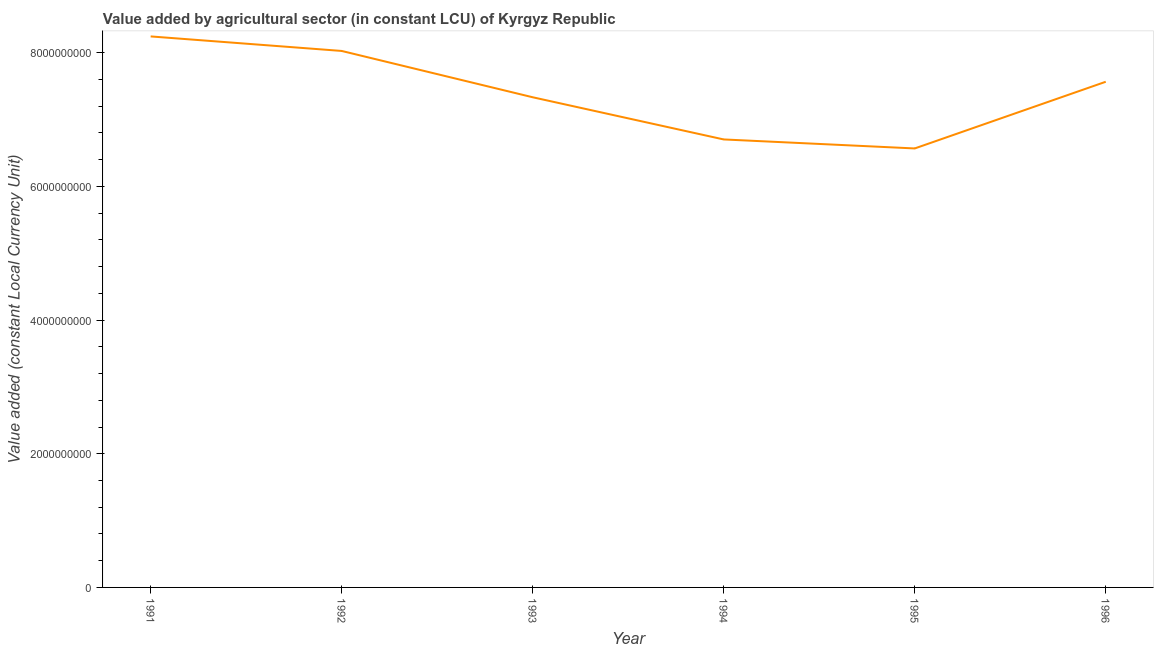What is the value added by agriculture sector in 1996?
Provide a succinct answer. 7.57e+09. Across all years, what is the maximum value added by agriculture sector?
Make the answer very short. 8.24e+09. Across all years, what is the minimum value added by agriculture sector?
Give a very brief answer. 6.57e+09. In which year was the value added by agriculture sector minimum?
Make the answer very short. 1995. What is the sum of the value added by agriculture sector?
Your answer should be very brief. 4.44e+1. What is the difference between the value added by agriculture sector in 1995 and 1996?
Provide a succinct answer. -9.98e+08. What is the average value added by agriculture sector per year?
Give a very brief answer. 7.41e+09. What is the median value added by agriculture sector?
Provide a succinct answer. 7.45e+09. What is the ratio of the value added by agriculture sector in 1991 to that in 1994?
Ensure brevity in your answer.  1.23. Is the value added by agriculture sector in 1992 less than that in 1994?
Your answer should be compact. No. What is the difference between the highest and the second highest value added by agriculture sector?
Provide a succinct answer. 2.17e+08. What is the difference between the highest and the lowest value added by agriculture sector?
Offer a very short reply. 1.68e+09. In how many years, is the value added by agriculture sector greater than the average value added by agriculture sector taken over all years?
Provide a short and direct response. 3. How many years are there in the graph?
Your response must be concise. 6. Does the graph contain grids?
Offer a very short reply. No. What is the title of the graph?
Your answer should be very brief. Value added by agricultural sector (in constant LCU) of Kyrgyz Republic. What is the label or title of the X-axis?
Provide a succinct answer. Year. What is the label or title of the Y-axis?
Your response must be concise. Value added (constant Local Currency Unit). What is the Value added (constant Local Currency Unit) of 1991?
Give a very brief answer. 8.24e+09. What is the Value added (constant Local Currency Unit) in 1992?
Your response must be concise. 8.03e+09. What is the Value added (constant Local Currency Unit) in 1993?
Give a very brief answer. 7.33e+09. What is the Value added (constant Local Currency Unit) in 1994?
Your answer should be compact. 6.70e+09. What is the Value added (constant Local Currency Unit) in 1995?
Offer a terse response. 6.57e+09. What is the Value added (constant Local Currency Unit) in 1996?
Your answer should be very brief. 7.57e+09. What is the difference between the Value added (constant Local Currency Unit) in 1991 and 1992?
Your answer should be compact. 2.17e+08. What is the difference between the Value added (constant Local Currency Unit) in 1991 and 1993?
Your answer should be compact. 9.10e+08. What is the difference between the Value added (constant Local Currency Unit) in 1991 and 1994?
Ensure brevity in your answer.  1.54e+09. What is the difference between the Value added (constant Local Currency Unit) in 1991 and 1995?
Your answer should be compact. 1.68e+09. What is the difference between the Value added (constant Local Currency Unit) in 1991 and 1996?
Ensure brevity in your answer.  6.78e+08. What is the difference between the Value added (constant Local Currency Unit) in 1992 and 1993?
Your response must be concise. 6.93e+08. What is the difference between the Value added (constant Local Currency Unit) in 1992 and 1994?
Offer a very short reply. 1.32e+09. What is the difference between the Value added (constant Local Currency Unit) in 1992 and 1995?
Your answer should be compact. 1.46e+09. What is the difference between the Value added (constant Local Currency Unit) in 1992 and 1996?
Provide a short and direct response. 4.61e+08. What is the difference between the Value added (constant Local Currency Unit) in 1993 and 1994?
Make the answer very short. 6.31e+08. What is the difference between the Value added (constant Local Currency Unit) in 1993 and 1995?
Ensure brevity in your answer.  7.66e+08. What is the difference between the Value added (constant Local Currency Unit) in 1993 and 1996?
Your response must be concise. -2.32e+08. What is the difference between the Value added (constant Local Currency Unit) in 1994 and 1995?
Offer a very short reply. 1.35e+08. What is the difference between the Value added (constant Local Currency Unit) in 1994 and 1996?
Provide a short and direct response. -8.63e+08. What is the difference between the Value added (constant Local Currency Unit) in 1995 and 1996?
Ensure brevity in your answer.  -9.98e+08. What is the ratio of the Value added (constant Local Currency Unit) in 1991 to that in 1993?
Your answer should be very brief. 1.12. What is the ratio of the Value added (constant Local Currency Unit) in 1991 to that in 1994?
Give a very brief answer. 1.23. What is the ratio of the Value added (constant Local Currency Unit) in 1991 to that in 1995?
Offer a terse response. 1.25. What is the ratio of the Value added (constant Local Currency Unit) in 1991 to that in 1996?
Your answer should be compact. 1.09. What is the ratio of the Value added (constant Local Currency Unit) in 1992 to that in 1993?
Provide a short and direct response. 1.09. What is the ratio of the Value added (constant Local Currency Unit) in 1992 to that in 1994?
Offer a terse response. 1.2. What is the ratio of the Value added (constant Local Currency Unit) in 1992 to that in 1995?
Keep it short and to the point. 1.22. What is the ratio of the Value added (constant Local Currency Unit) in 1992 to that in 1996?
Offer a very short reply. 1.06. What is the ratio of the Value added (constant Local Currency Unit) in 1993 to that in 1994?
Your response must be concise. 1.09. What is the ratio of the Value added (constant Local Currency Unit) in 1993 to that in 1995?
Provide a short and direct response. 1.12. What is the ratio of the Value added (constant Local Currency Unit) in 1993 to that in 1996?
Keep it short and to the point. 0.97. What is the ratio of the Value added (constant Local Currency Unit) in 1994 to that in 1995?
Make the answer very short. 1.02. What is the ratio of the Value added (constant Local Currency Unit) in 1994 to that in 1996?
Give a very brief answer. 0.89. What is the ratio of the Value added (constant Local Currency Unit) in 1995 to that in 1996?
Make the answer very short. 0.87. 